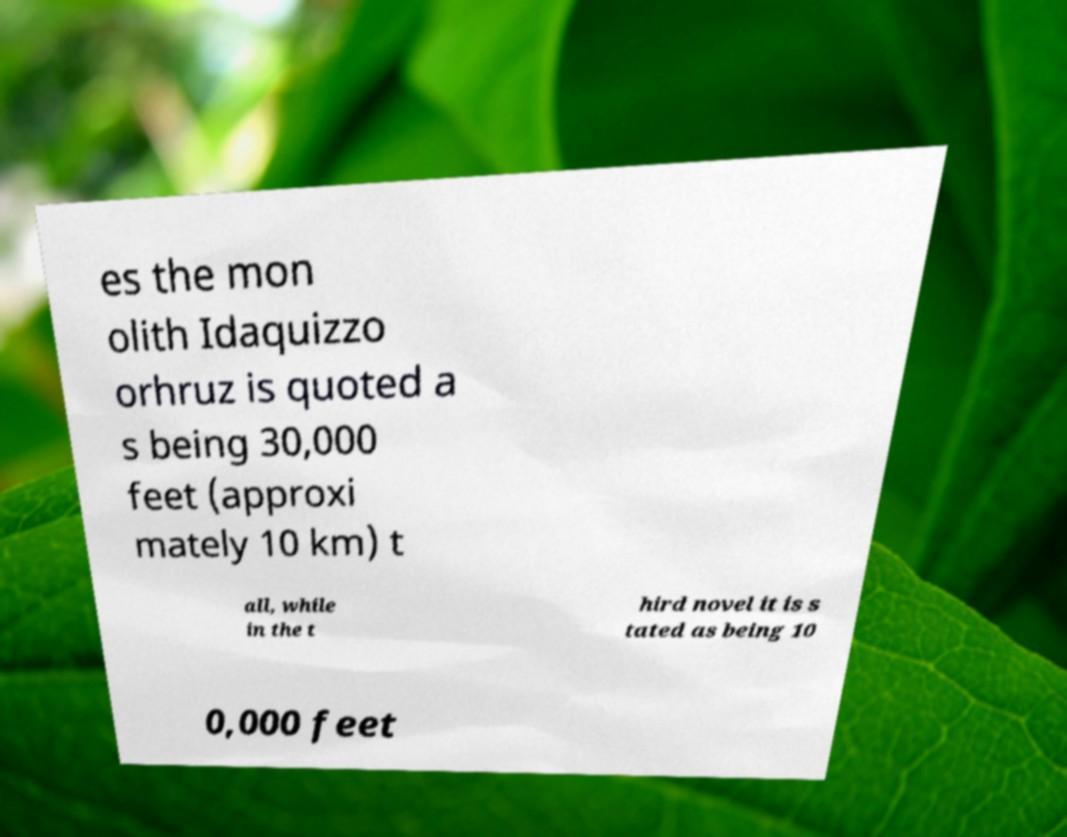Can you accurately transcribe the text from the provided image for me? es the mon olith Idaquizzo orhruz is quoted a s being 30,000 feet (approxi mately 10 km) t all, while in the t hird novel it is s tated as being 10 0,000 feet 